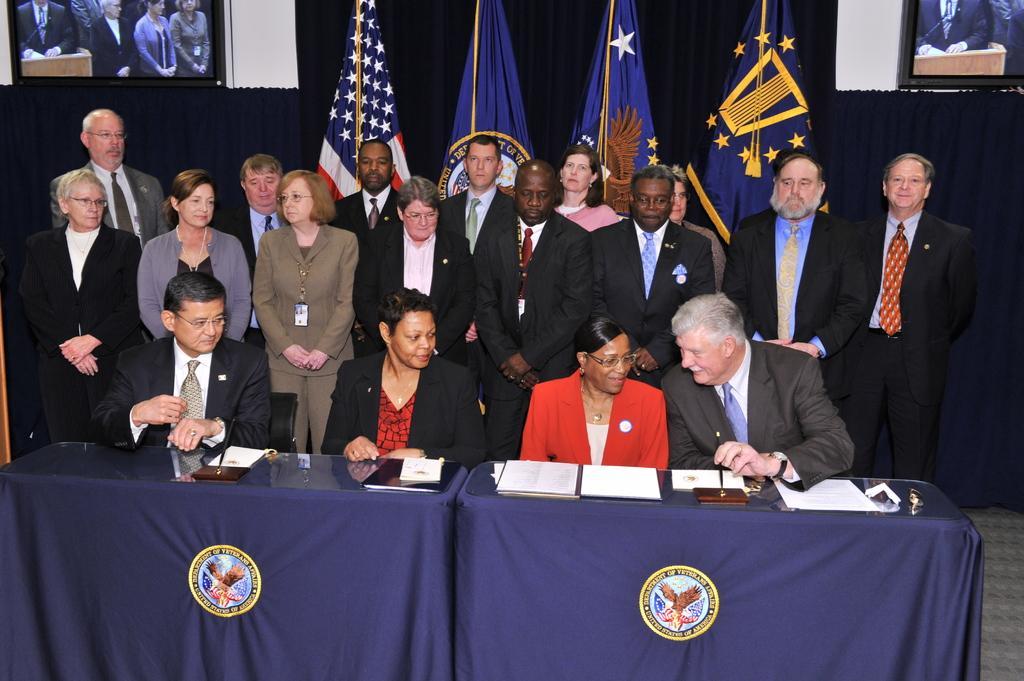Can you describe this image briefly? In this picture we can see a few people sitting on the chair. We can see some people are standing at the back. There are a few papers, glass objects and other objects are visible on the tables. There are logos and some text is visible on the blue clothes. We can see a few flags. There are some screens. We can see a few people on these screens. There are clothes visible in the background. 